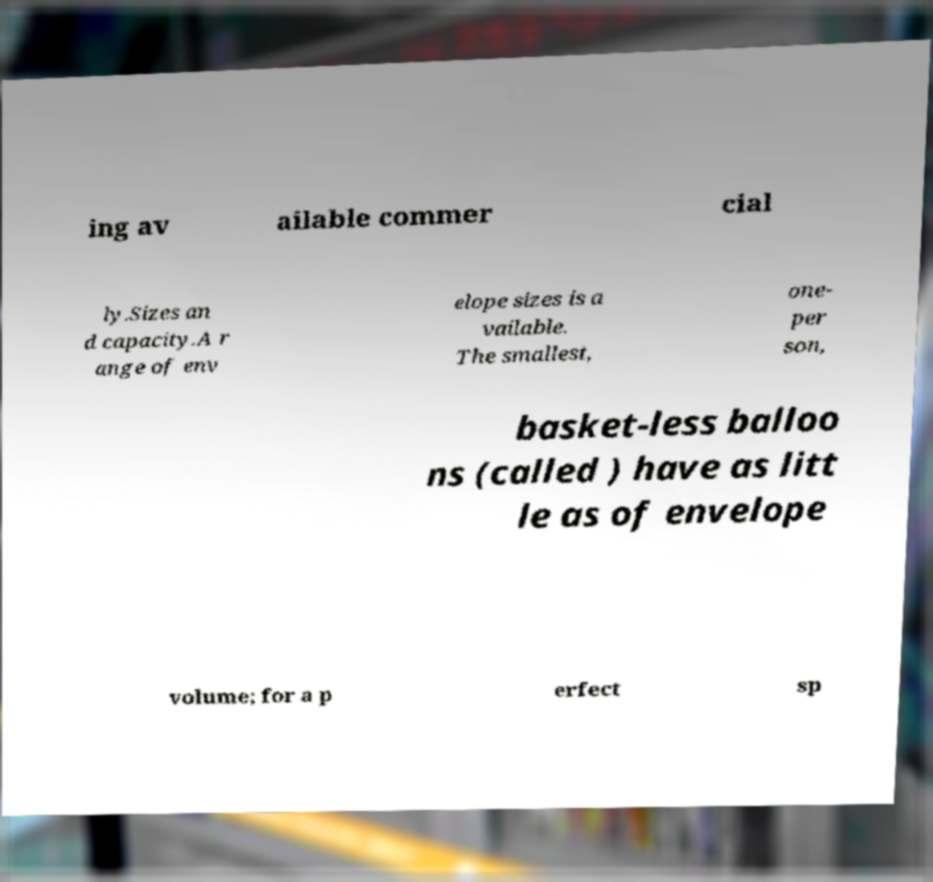Can you accurately transcribe the text from the provided image for me? ing av ailable commer cial ly.Sizes an d capacity.A r ange of env elope sizes is a vailable. The smallest, one- per son, basket-less balloo ns (called ) have as litt le as of envelope volume; for a p erfect sp 